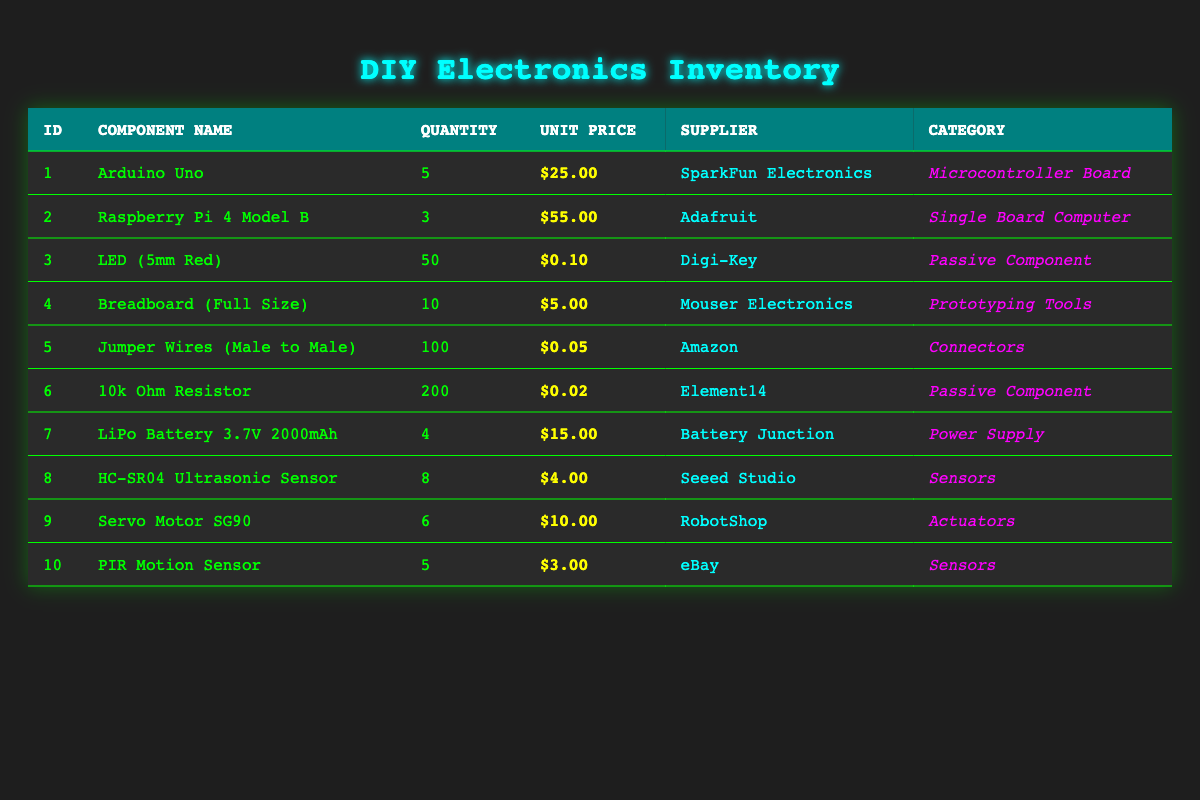What is the total quantity of LED components in the inventory? The inventory shows that there are 50 LED (5mm Red) components. Since it's the only entry for LED components, the total quantity is directly the quantity listed.
Answer: 50 Which component has the highest unit price? To find the highest unit price, we compare all listed unit prices: Arduino Uno ($25.00), Raspberry Pi 4 Model B ($55.00), LED (5mm Red) ($0.10), Breadboard (Full Size) ($5.00), Jumper Wires (Male to Male) ($0.05), 10k Ohm Resistor ($0.02), LiPo Battery 3.7V 2000mAh ($15.00), HC-SR04 Ultrasonic Sensor ($4.00), Servo Motor SG90 ($10.00), PIR Motion Sensor ($3.00). The highest is Raspberry Pi 4 Model B at $55.00.
Answer: Raspberry Pi 4 Model B How many components belong to the "Sensors" category? By examining the inventory, we find the entries classified under the "Sensors" category. There are two components: the HC-SR04 Ultrasonic Sensor and the PIR Motion Sensor. Thus, there are 2 components in total.
Answer: 2 What is the total value of all Jumper Wires and Resistors combined? To find the total value, we first calculate the value of Jumper Wires: 100 wires at $0.05 each equals $5.00. Next, the value of 200 resistors at $0.02 each equals $4.00. Adding these together gives $5.00 + $4.00 = $9.00.
Answer: 9.00 Is there a component with zero quantity in the inventory? Checking the quantity listed for each component indicates that all components have a positive quantity. Therefore, none of them have a zero quantity.
Answer: No What is the total quantity of components in the inventory? We sum the quantities of each component: 5 + 3 + 50 + 10 + 100 + 200 + 4 + 8 + 6 + 5 = 391. Thus, the total quantity of components in the inventory amounts to 391.
Answer: 391 Which supplier provides the most components listed in the inventory? By reviewing the supplier information, we tally the components: SparkFun Electronics (1), Adafruit (1), Digi-Key (1), Mouser Electronics (1), Amazon (1), Element14 (1), Battery Junction (1), Seeed Studio (1), RobotShop (1), eBay (1). Each supplier only has one component listed, meaning no supplier provides more components than others.
Answer: None How much would it cost to buy all the Raspberry Pi and Servo Motors in the inventory? The cost of the Raspberry Pi is $55.00 per unit, and there are 3 units, totaling $165.00 (3 x $55.00). The Servo Motor costs $10.00 each, and there are 6 units, giving $60.00 (6 x $10.00). The overall expense is $165.00 + $60.00 = $225.00.
Answer: 225.00 What is the average unit price of all components listed? We add up all the unit prices: $25.00 + $55.00 + $0.10 + $5.00 + $0.05 + $0.02 + $15.00 + $4.00 + $10.00 + $3.00 = $113.17. Dividing this by the number of components (10) gives an average unit price of $11.32 ($113.17 / 10).
Answer: 11.32 